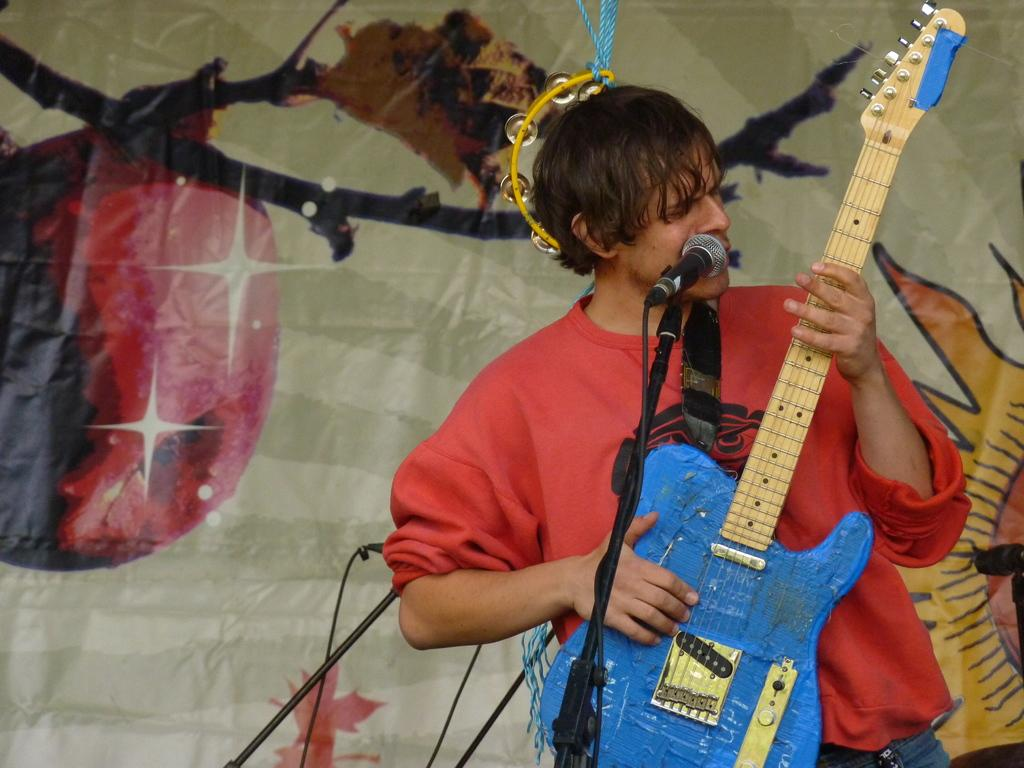What is the person in the image doing? The person is standing and holding a guitar, and they are singing. What can be seen in the background of the image? There is a banner and musical instruments in the background. What is the person using to amplify their voice? There is a microphone with a stand in the image. What type of war is being discussed at the meeting in the image? There is no meeting or war present in the image; it features a person singing with a guitar. Who is the porter assisting in the image? There is no porter present in the image. 